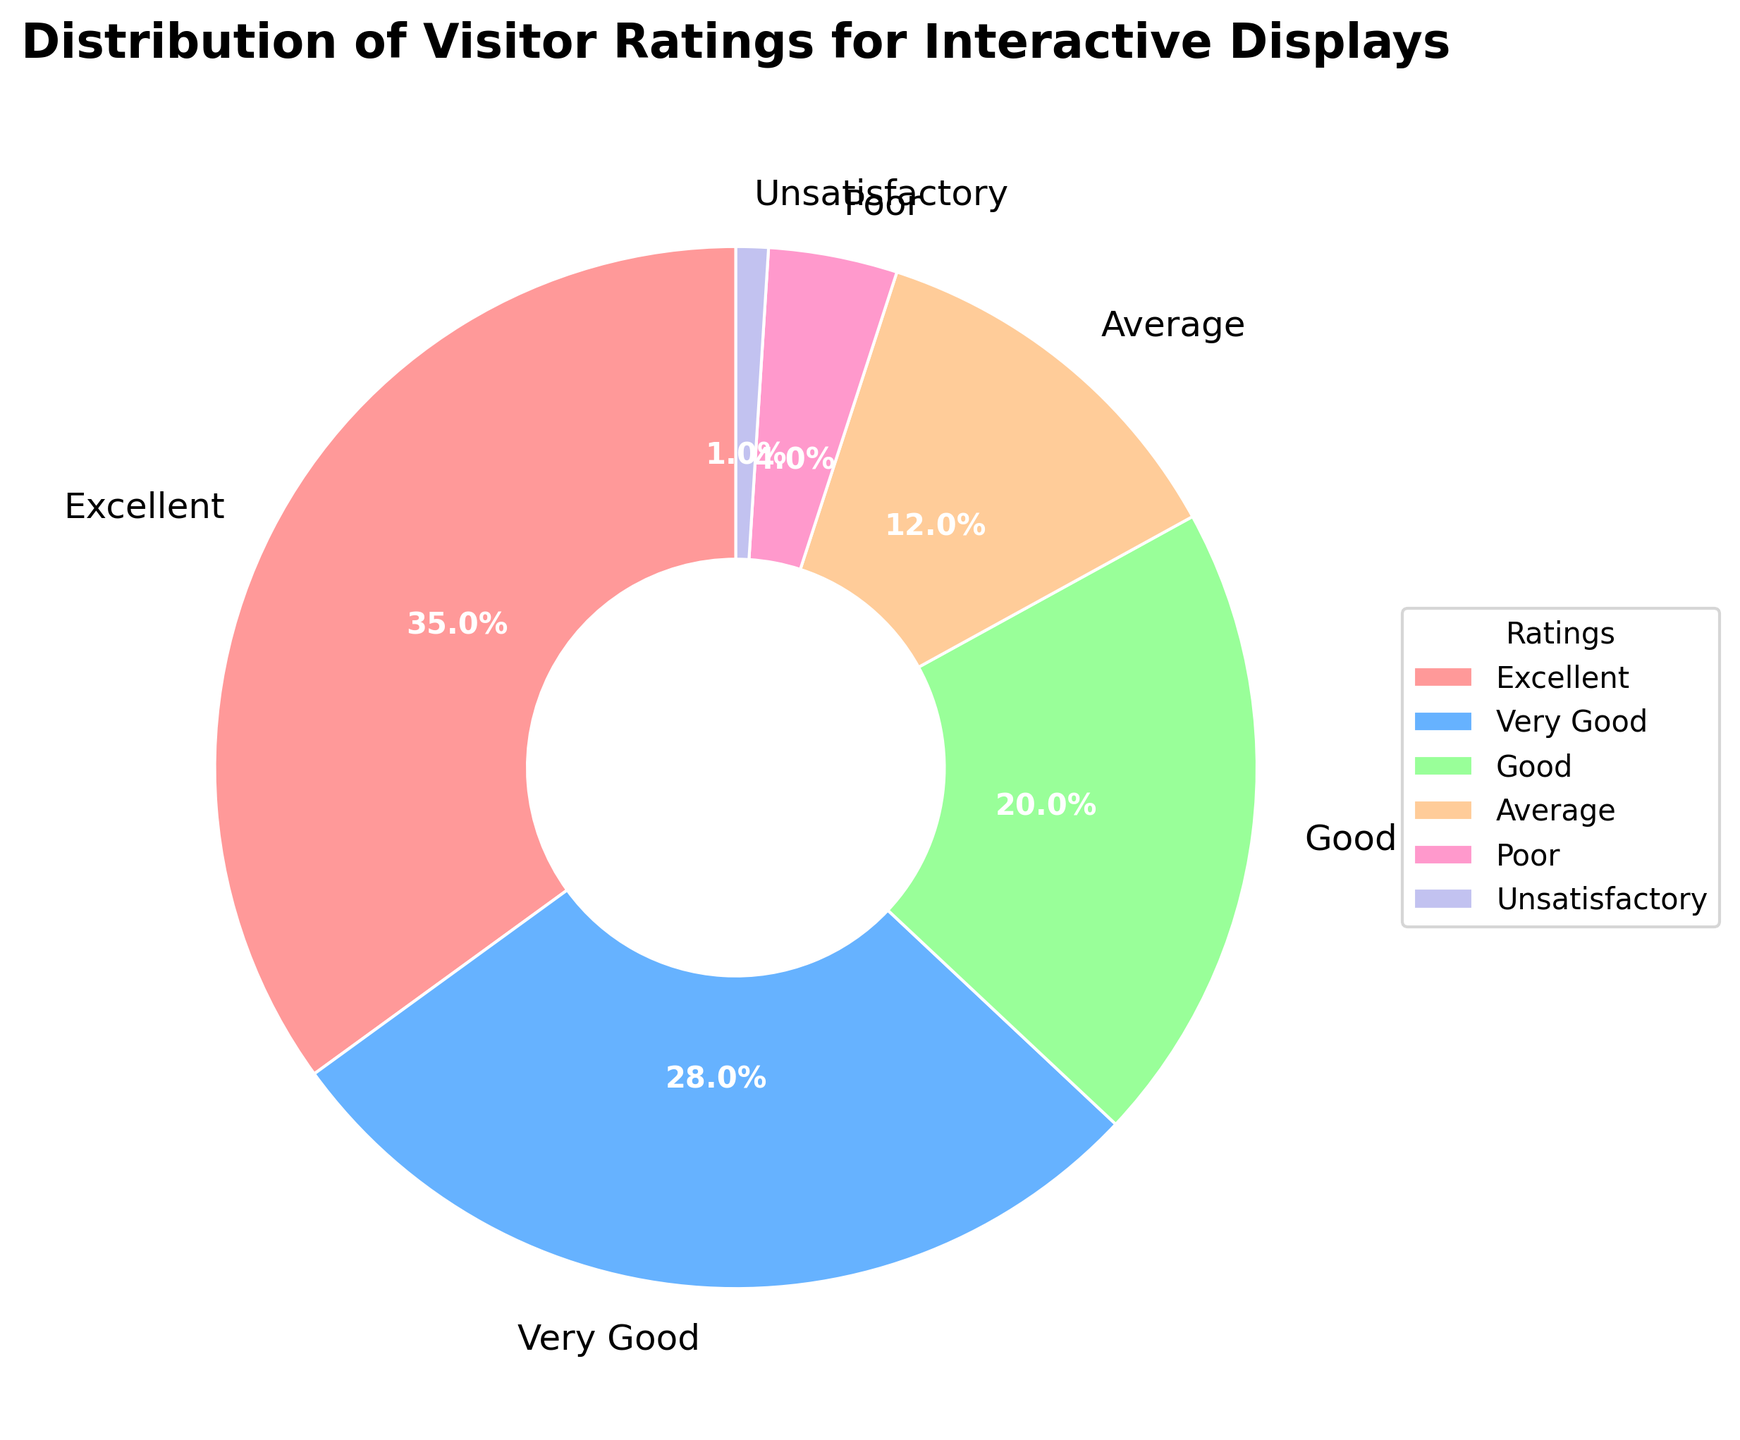What percentage of visitors rated the interactive displays as "Very Good"? The pie chart shows the percentages of visitor ratings. The segment labeled "Very Good" has a value indicated directly on the chart.
Answer: 28% Which rating category has the smallest percentage of visitors? The smallest segment in the pie chart corresponds to the "Unsatisfactory" rating, which is clearly marked and can be visually identified as the smallest wedge.
Answer: Unsatisfactory What is the combined percentage of visitors who rated the displays as "Excellent" or "Very Good"? Add the percentages for the "Excellent" and "Very Good" categories: 35% + 28% = 63%.
Answer: 63% How much higher is the percentage of "Excellent" ratings compared to "Poor" ratings? Subtract the percentage of "Poor" ratings from the percentage of "Excellent" ratings: 35% - 4% = 31%.
Answer: 31% Compare the percentage of "Good" ratings to "Average" ratings. Which is higher and by how much? The "Good" rating is 20%, and the "Average" rating is 12%. Subtract the "Average" percentage from the "Good" percentage: 20% - 12% = 8%. "Good" is higher by 8%.
Answer: Good is higher by 8% Which segment in the pie chart has the second largest percentage? By visual inspection of the segments and their associated percentages, the second largest segment is the one labeled "Very Good" with 28%.
Answer: Very Good How many percentage points more is the "Excellent" rating compared to "Average" and "Poor" combined? First, sum the percentages of "Average" and "Poor": 12% + 4% = 16%. Then, subtract this sum from the "Excellent" rating: 35% - 16% = 19%.
Answer: 19% What is the total percentage of visitors who rated the displays as "Good" or better (Good, Very Good, and Excellent)? Add the percentages for the "Good," "Very Good," and "Excellent" categories: 20% + 28% + 35% = 83%.
Answer: 83% 